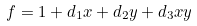Convert formula to latex. <formula><loc_0><loc_0><loc_500><loc_500>f = 1 + d _ { 1 } x + d _ { 2 } y + d _ { 3 } x y</formula> 